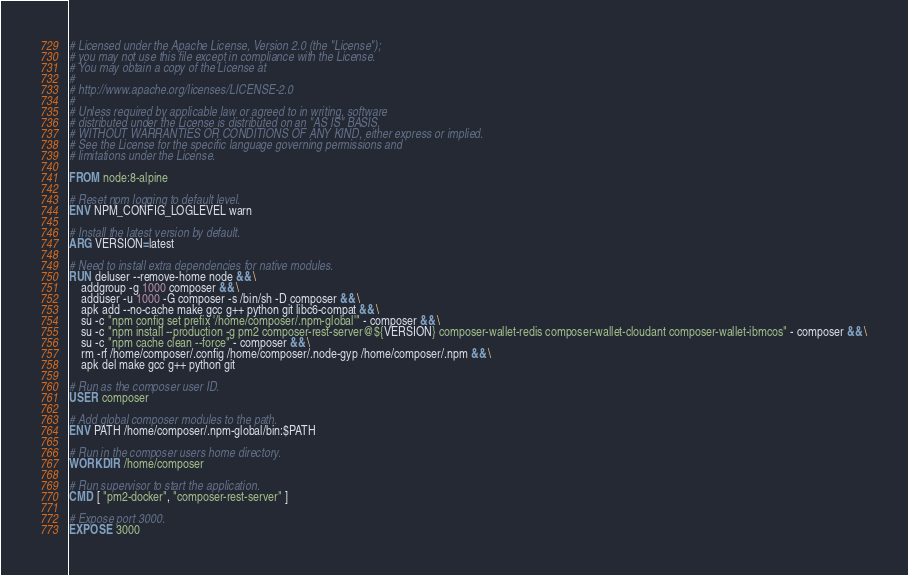<code> <loc_0><loc_0><loc_500><loc_500><_Dockerfile_># Licensed under the Apache License, Version 2.0 (the "License");
# you may not use this file except in compliance with the License.
# You may obtain a copy of the License at
#
# http://www.apache.org/licenses/LICENSE-2.0
#
# Unless required by applicable law or agreed to in writing, software
# distributed under the License is distributed on an "AS IS" BASIS,
# WITHOUT WARRANTIES OR CONDITIONS OF ANY KIND, either express or implied.
# See the License for the specific language governing permissions and
# limitations under the License.

FROM node:8-alpine

# Reset npm logging to default level.
ENV NPM_CONFIG_LOGLEVEL warn

# Install the latest version by default.
ARG VERSION=latest

# Need to install extra dependencies for native modules.
RUN deluser --remove-home node && \
    addgroup -g 1000 composer && \
    adduser -u 1000 -G composer -s /bin/sh -D composer && \
    apk add --no-cache make gcc g++ python git libc6-compat && \
    su -c "npm config set prefix '/home/composer/.npm-global'" - composer && \
    su -c "npm install --production -g pm2 composer-rest-server@${VERSION} composer-wallet-redis composer-wallet-cloudant composer-wallet-ibmcos" - composer && \
    su -c "npm cache clean --force" - composer && \
    rm -rf /home/composer/.config /home/composer/.node-gyp /home/composer/.npm && \
    apk del make gcc g++ python git

# Run as the composer user ID.
USER composer

# Add global composer modules to the path.
ENV PATH /home/composer/.npm-global/bin:$PATH

# Run in the composer users home directory.
WORKDIR /home/composer

# Run supervisor to start the application.
CMD [ "pm2-docker", "composer-rest-server" ]

# Expose port 3000.
EXPOSE 3000
</code> 